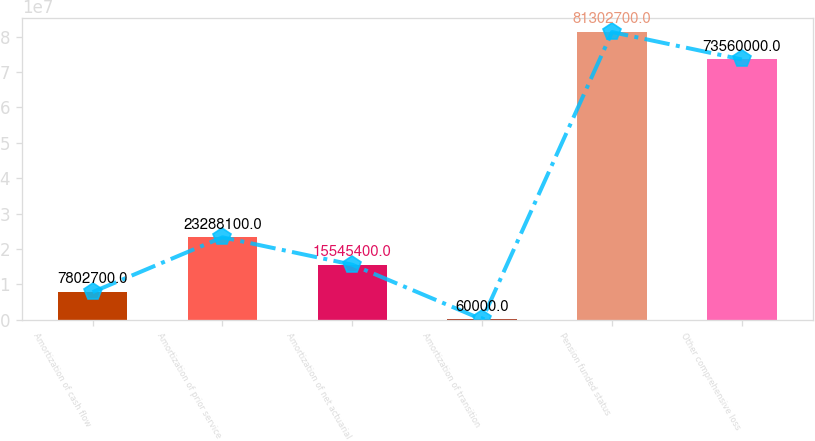Convert chart to OTSL. <chart><loc_0><loc_0><loc_500><loc_500><bar_chart><fcel>Amortization of cash flow<fcel>Amortization of prior service<fcel>Amortization of net actuarial<fcel>Amortization of transition<fcel>Pension funded status<fcel>Other comprehensive loss<nl><fcel>7.8027e+06<fcel>2.32881e+07<fcel>1.55454e+07<fcel>60000<fcel>8.13027e+07<fcel>7.356e+07<nl></chart> 